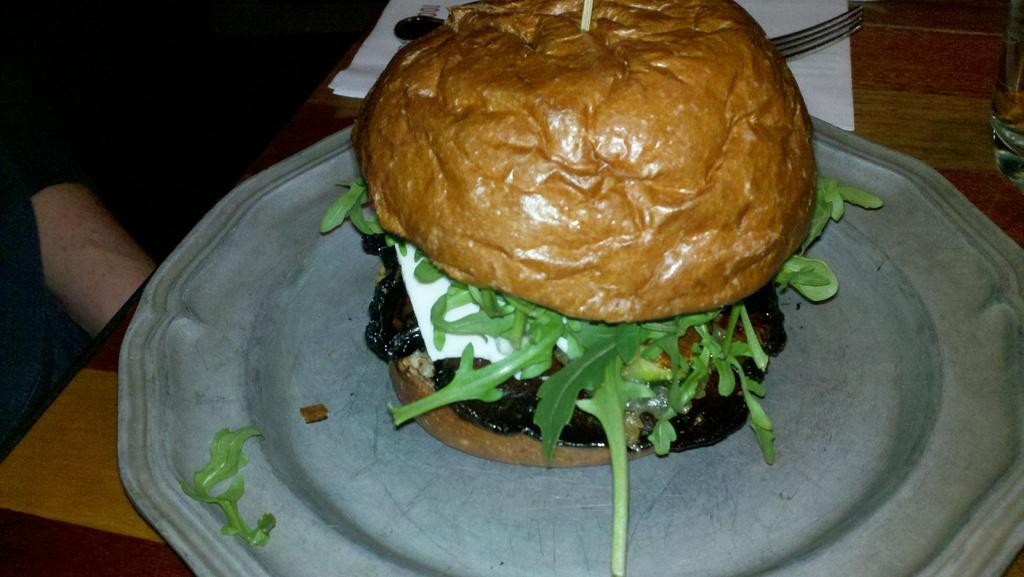What body part is visible in the image? There is a human hand in the image. What object is present for holding or serving food? There is a plate in the image. What is on the plate? There is a food item on the plate. What item might be used for cleaning or wiping in the image? There is tissue paper in the image. What utensil is present for eating the food item? There is a fork in the image. What container is present for holding a beverage? There is a glass in the image. What type of wren can be seen in the image? There is no wren present in the image; it features a human hand, a plate, a food item, tissue paper, a fork, and a glass. What grade is the alley mentioned in the image? There is no alley or grade mentioned in the image. 